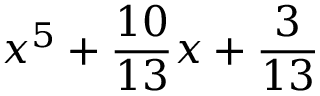<formula> <loc_0><loc_0><loc_500><loc_500>x ^ { 5 } + { \frac { 1 0 } { 1 3 } } x + { \frac { 3 } { 1 3 } }</formula> 